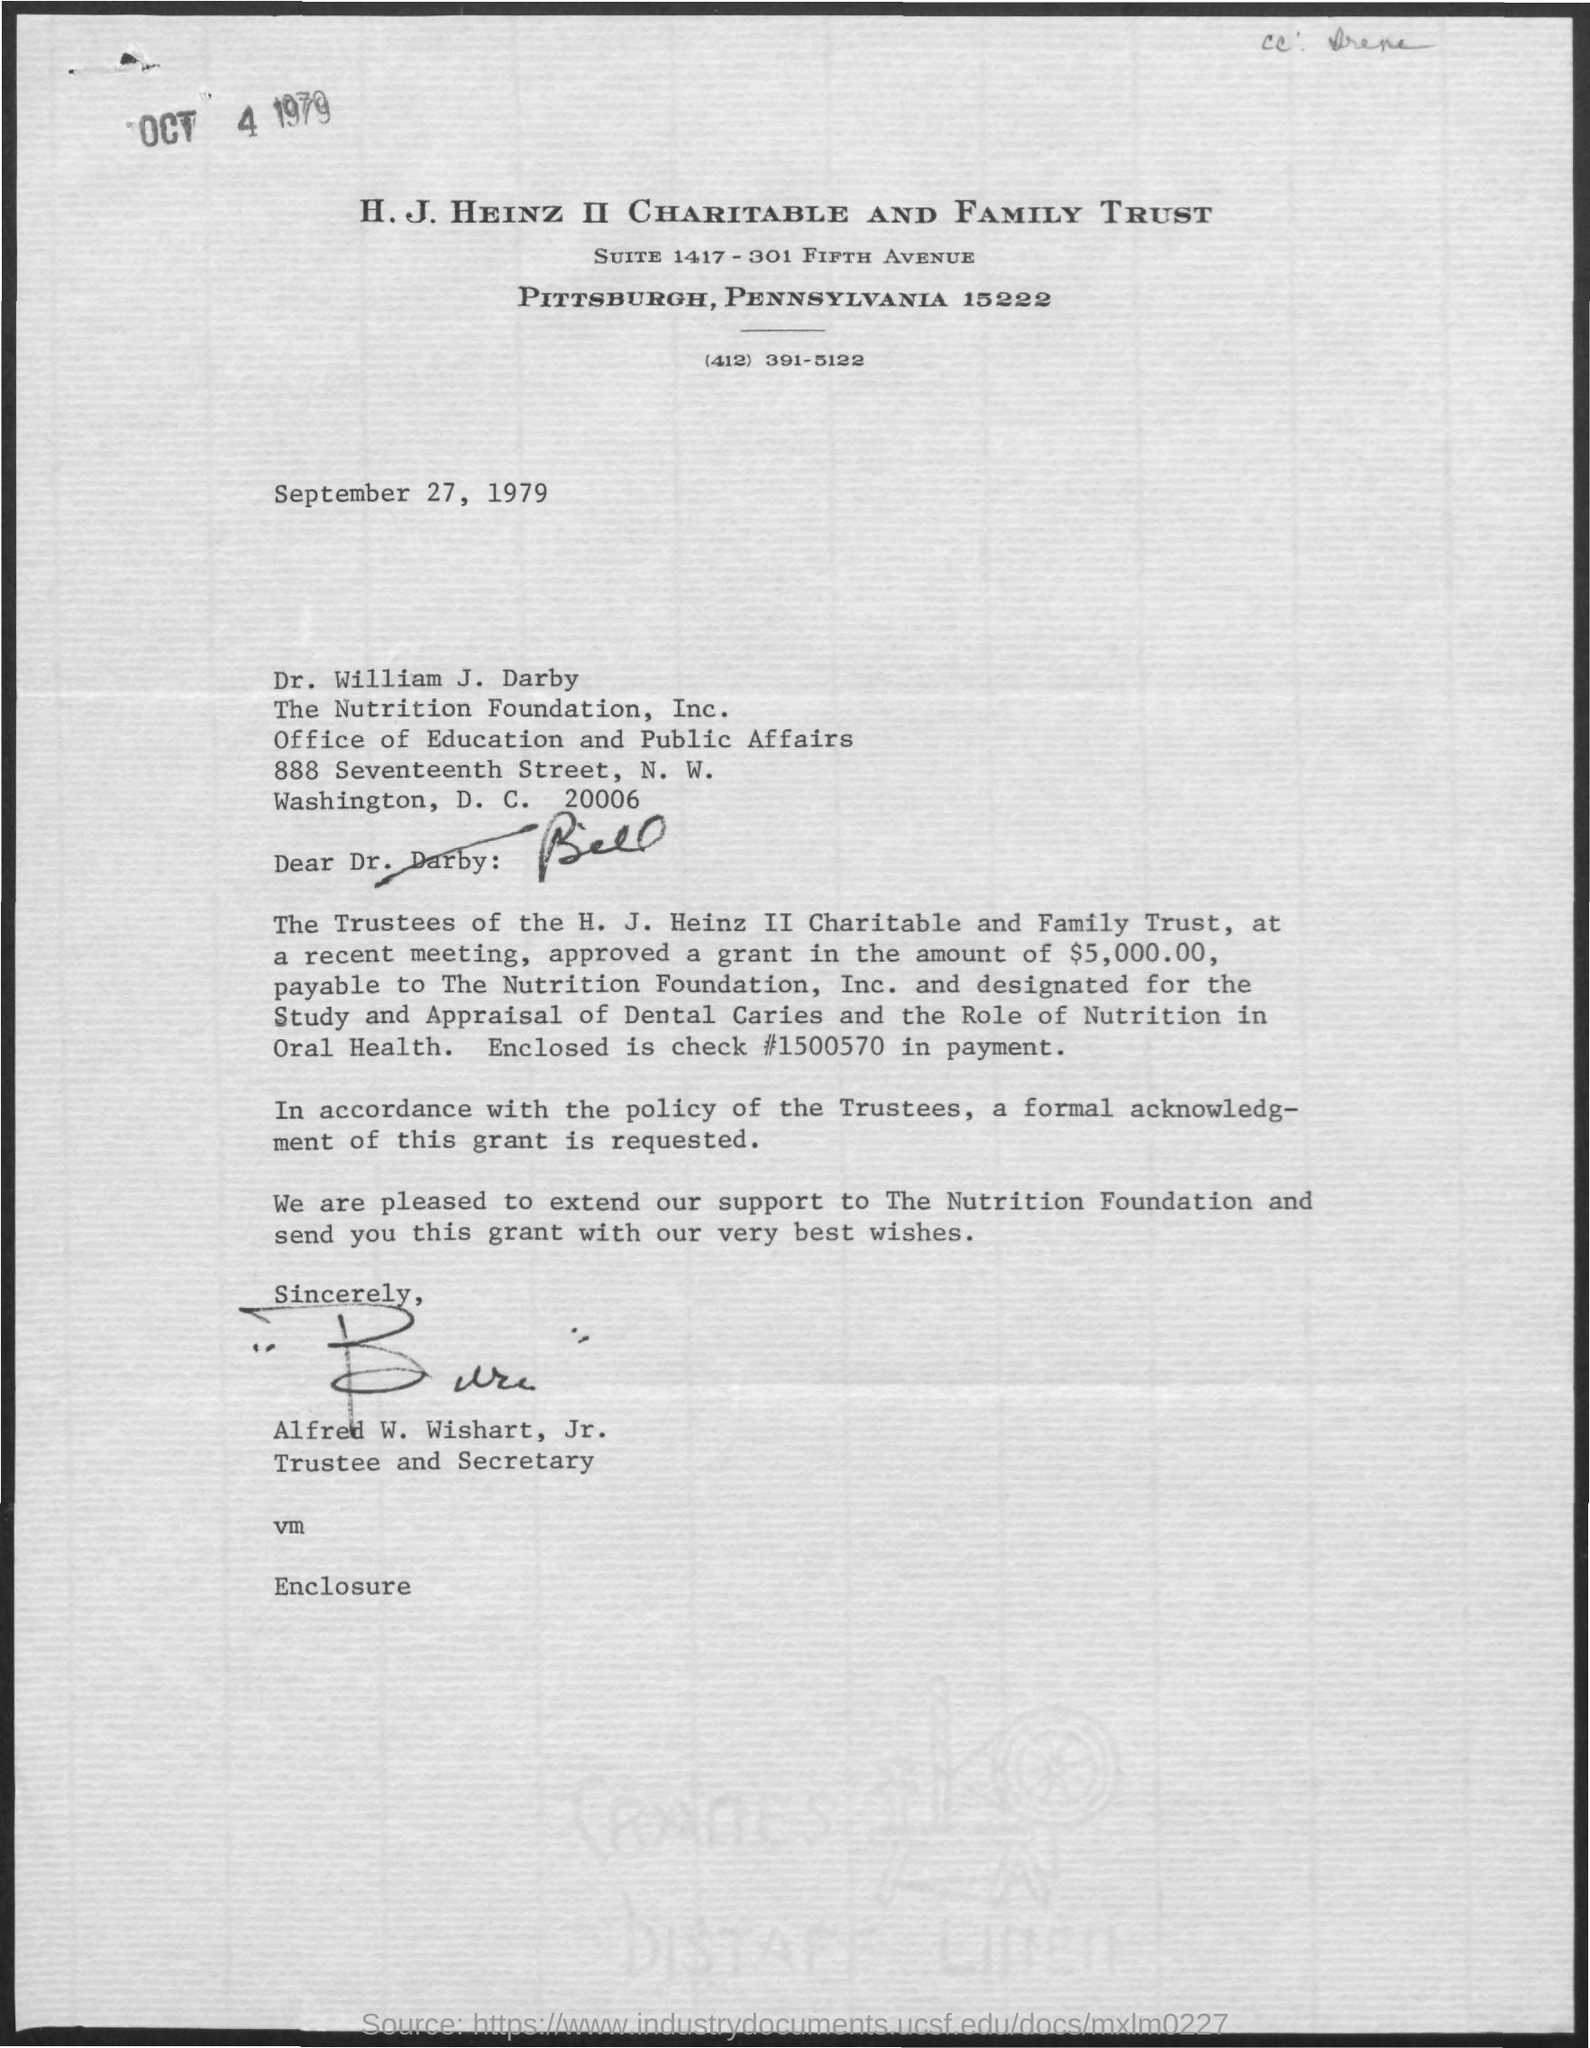Highlight a few significant elements in this photo. Alfred W. Wishart, Jr. holds the designation of Trustee and Secretary. The letter has been signed by Alfred W. Wishart, Jr. 